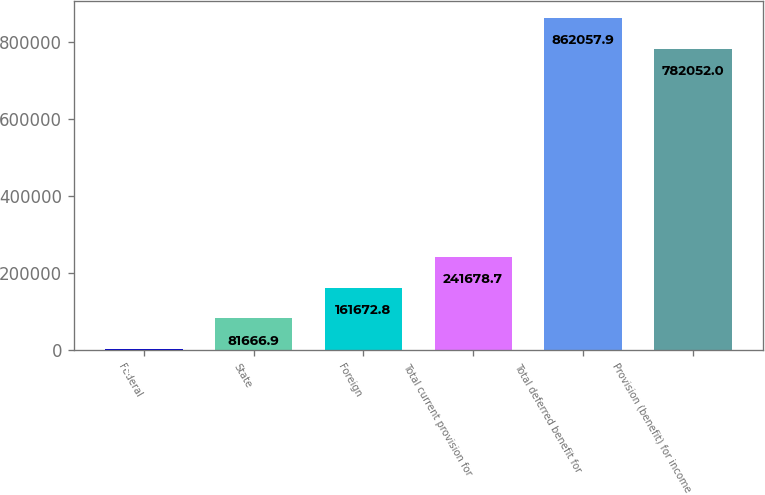Convert chart. <chart><loc_0><loc_0><loc_500><loc_500><bar_chart><fcel>Federal<fcel>State<fcel>Foreign<fcel>Total current provision for<fcel>Total deferred benefit for<fcel>Provision (benefit) for income<nl><fcel>1661<fcel>81666.9<fcel>161673<fcel>241679<fcel>862058<fcel>782052<nl></chart> 